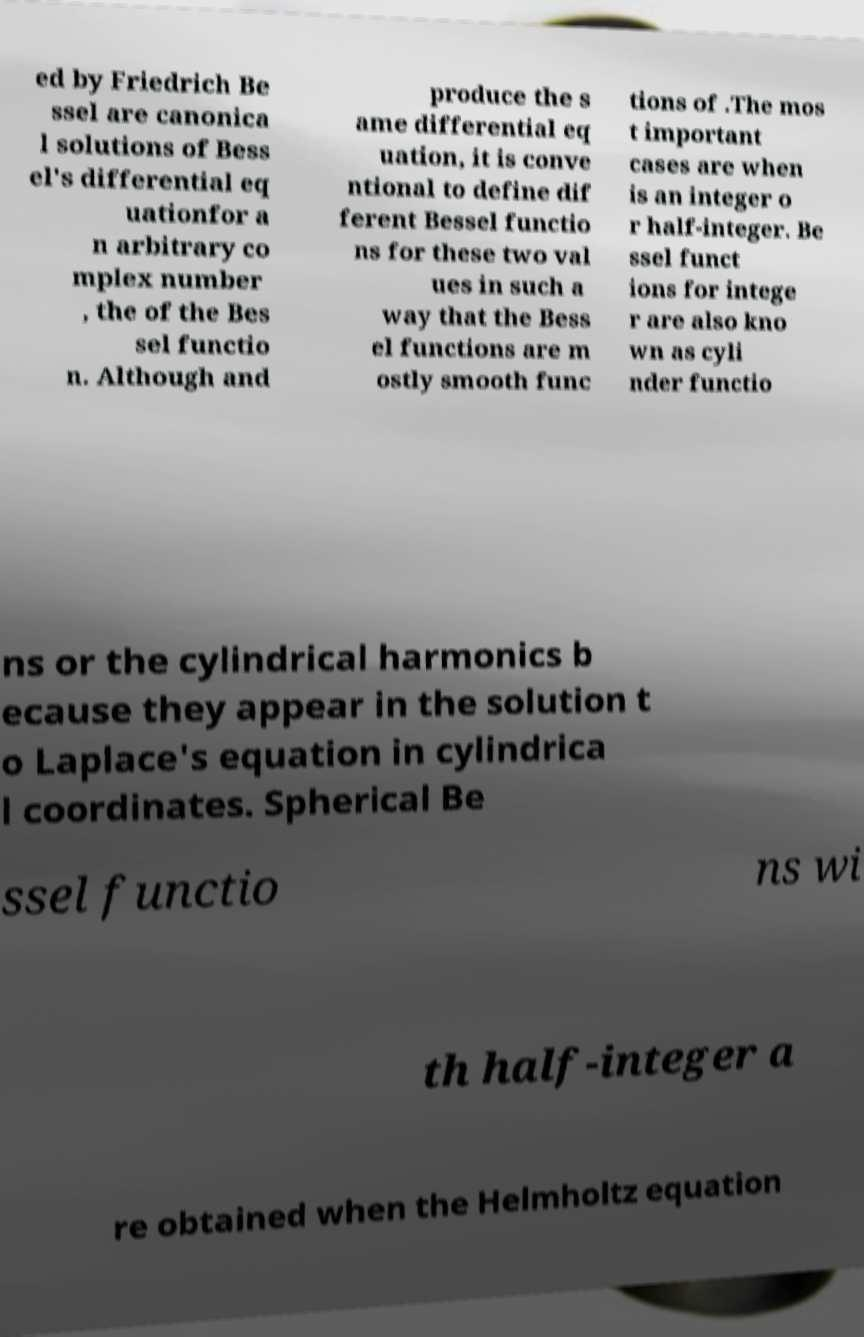I need the written content from this picture converted into text. Can you do that? ed by Friedrich Be ssel are canonica l solutions of Bess el's differential eq uationfor a n arbitrary co mplex number , the of the Bes sel functio n. Although and produce the s ame differential eq uation, it is conve ntional to define dif ferent Bessel functio ns for these two val ues in such a way that the Bess el functions are m ostly smooth func tions of .The mos t important cases are when is an integer o r half-integer. Be ssel funct ions for intege r are also kno wn as cyli nder functio ns or the cylindrical harmonics b ecause they appear in the solution t o Laplace's equation in cylindrica l coordinates. Spherical Be ssel functio ns wi th half-integer a re obtained when the Helmholtz equation 